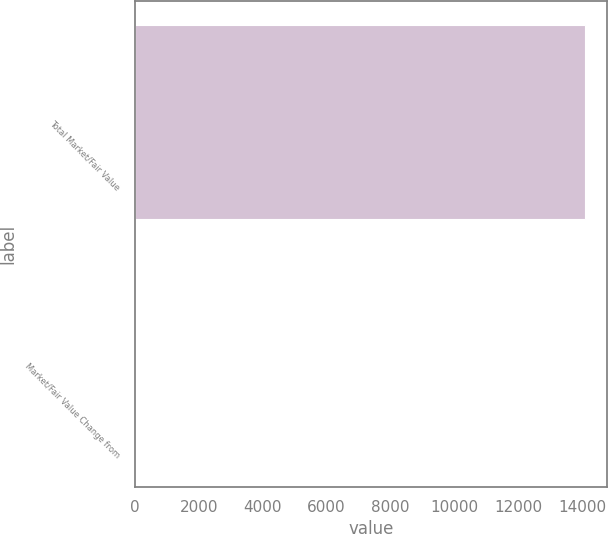Convert chart. <chart><loc_0><loc_0><loc_500><loc_500><bar_chart><fcel>Total Market/Fair Value<fcel>Market/Fair Value Change from<nl><fcel>14078.1<fcel>3.2<nl></chart> 